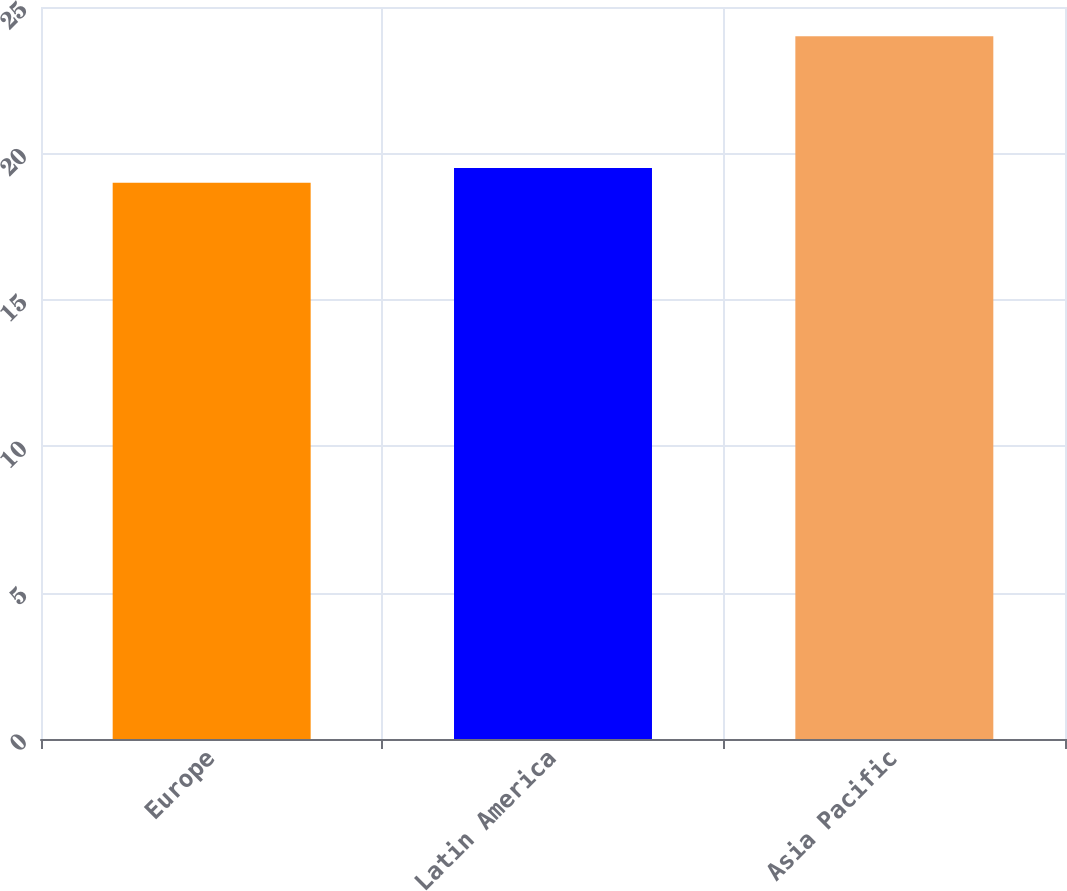<chart> <loc_0><loc_0><loc_500><loc_500><bar_chart><fcel>Europe<fcel>Latin America<fcel>Asia Pacific<nl><fcel>19<fcel>19.5<fcel>24<nl></chart> 